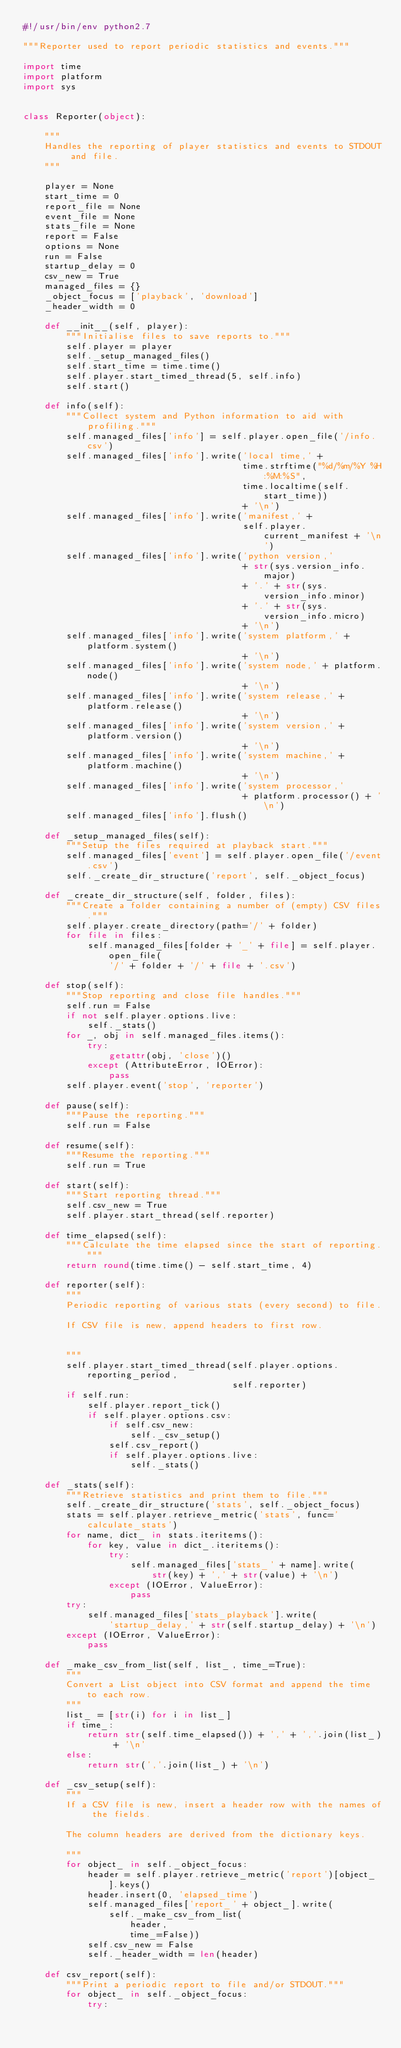Convert code to text. <code><loc_0><loc_0><loc_500><loc_500><_Python_>#!/usr/bin/env python2.7

"""Reporter used to report periodic statistics and events."""

import time
import platform
import sys


class Reporter(object):

    """
    Handles the reporting of player statistics and events to STDOUT and file.
    """

    player = None
    start_time = 0
    report_file = None
    event_file = None
    stats_file = None
    report = False
    options = None
    run = False
    startup_delay = 0
    csv_new = True
    managed_files = {}
    _object_focus = ['playback', 'download']
    _header_width = 0

    def __init__(self, player):
        """Initialise files to save reports to."""
        self.player = player
        self._setup_managed_files()
        self.start_time = time.time()
        self.player.start_timed_thread(5, self.info)
        self.start()

    def info(self):
        """Collect system and Python information to aid with profiling."""
        self.managed_files['info'] = self.player.open_file('/info.csv')
        self.managed_files['info'].write('local time,' +
                                         time.strftime("%d/%m/%Y %H:%M:%S",
                                         time.localtime(self.start_time))
                                         + '\n')
        self.managed_files['info'].write('manifest,' +
                                         self.player.current_manifest + '\n')
        self.managed_files['info'].write('python version,'
                                         + str(sys.version_info.major)
                                         + '.' + str(sys.version_info.minor)
                                         + '.' + str(sys.version_info.micro)
                                         + '\n')
        self.managed_files['info'].write('system platform,' + platform.system()
                                         + '\n')
        self.managed_files['info'].write('system node,' + platform.node()
                                         + '\n')
        self.managed_files['info'].write('system release,' + platform.release()
                                         + '\n')
        self.managed_files['info'].write('system version,' + platform.version()
                                         + '\n')
        self.managed_files['info'].write('system machine,' + platform.machine()
                                         + '\n')
        self.managed_files['info'].write('system processor,'
                                         + platform.processor() + '\n')
        self.managed_files['info'].flush()

    def _setup_managed_files(self):
        """Setup the files required at playback start."""
        self.managed_files['event'] = self.player.open_file('/event.csv')
        self._create_dir_structure('report', self._object_focus)

    def _create_dir_structure(self, folder, files):
        """Create a folder containing a number of (empty) CSV files."""
        self.player.create_directory(path='/' + folder)
        for file in files:
            self.managed_files[folder + '_' + file] = self.player.open_file(
                '/' + folder + '/' + file + '.csv')

    def stop(self):
        """Stop reporting and close file handles."""
        self.run = False
        if not self.player.options.live:
            self._stats()
        for _, obj in self.managed_files.items():
            try:
                getattr(obj, 'close')()
            except (AttributeError, IOError):
                pass
        self.player.event('stop', 'reporter')

    def pause(self):
        """Pause the reporting."""
        self.run = False

    def resume(self):
        """Resume the reporting."""
        self.run = True

    def start(self):
        """Start reporting thread."""
        self.csv_new = True
        self.player.start_thread(self.reporter)

    def time_elapsed(self):
        """Calculate the time elapsed since the start of reporting."""
        return round(time.time() - self.start_time, 4)

    def reporter(self):
        """
        Periodic reporting of various stats (every second) to file.

        If CSV file is new, append headers to first row.


        """
        self.player.start_timed_thread(self.player.options.reporting_period,
                                       self.reporter)
        if self.run:
            self.player.report_tick()
            if self.player.options.csv:
                if self.csv_new:
                    self._csv_setup()
                self.csv_report()
                if self.player.options.live:
                    self._stats()

    def _stats(self):
        """Retrieve statistics and print them to file."""
        self._create_dir_structure('stats', self._object_focus)
        stats = self.player.retrieve_metric('stats', func='calculate_stats')
        for name, dict_ in stats.iteritems():
            for key, value in dict_.iteritems():
                try:
                    self.managed_files['stats_' + name].write(
                        str(key) + ',' + str(value) + '\n')
                except (IOError, ValueError):
                    pass
        try:
            self.managed_files['stats_playback'].write(
                'startup_delay,' + str(self.startup_delay) + '\n')
        except (IOError, ValueError):
            pass

    def _make_csv_from_list(self, list_, time_=True):
        """
        Convert a List object into CSV format and append the time to each row.
        """
        list_ = [str(i) for i in list_]
        if time_:
            return str(self.time_elapsed()) + ',' + ','.join(list_) + '\n'
        else:
            return str(','.join(list_) + '\n')

    def _csv_setup(self):
        """
        If a CSV file is new, insert a header row with the names of the fields.

        The column headers are derived from the dictionary keys.

        """
        for object_ in self._object_focus:
            header = self.player.retrieve_metric('report')[object_].keys()
            header.insert(0, 'elapsed_time')
            self.managed_files['report_' + object_].write(
                self._make_csv_from_list(
                    header,
                    time_=False))
            self.csv_new = False
            self._header_width = len(header)

    def csv_report(self):
        """Print a periodic report to file and/or STDOUT."""
        for object_ in self._object_focus:
            try:</code> 